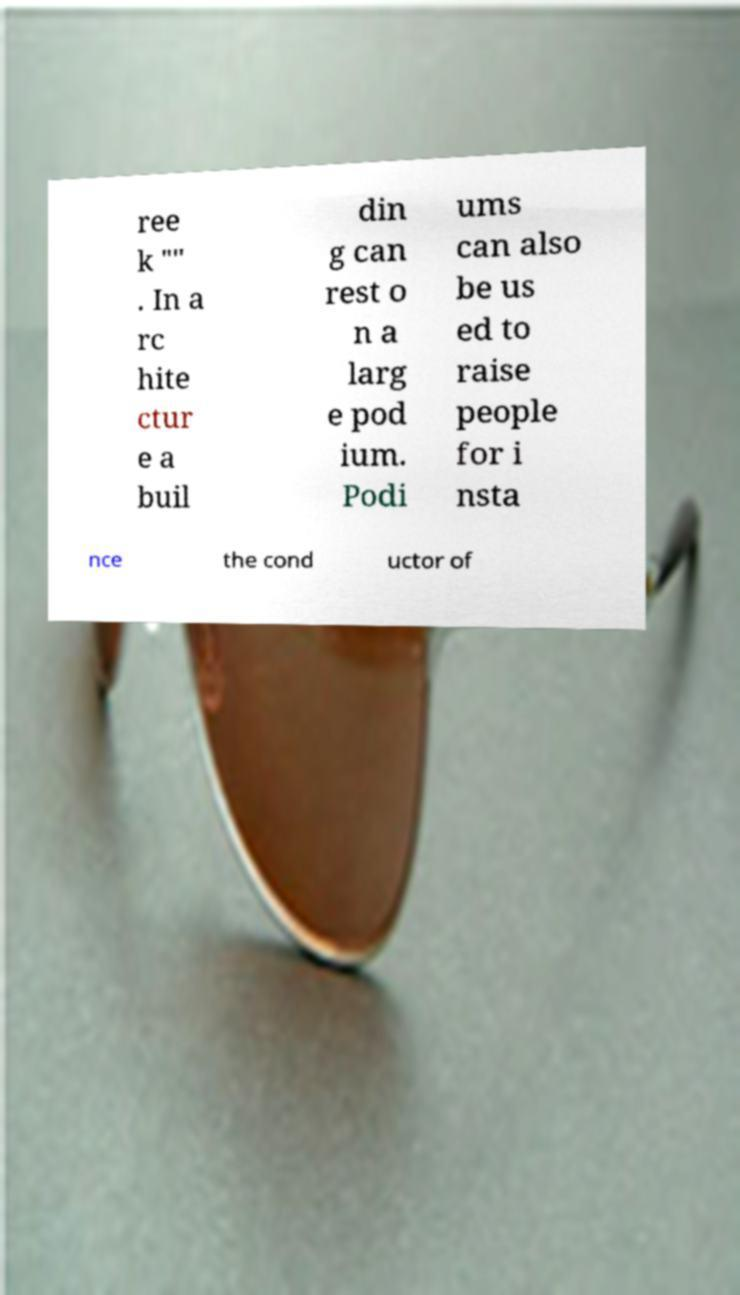Please identify and transcribe the text found in this image. ree k "" . In a rc hite ctur e a buil din g can rest o n a larg e pod ium. Podi ums can also be us ed to raise people for i nsta nce the cond uctor of 